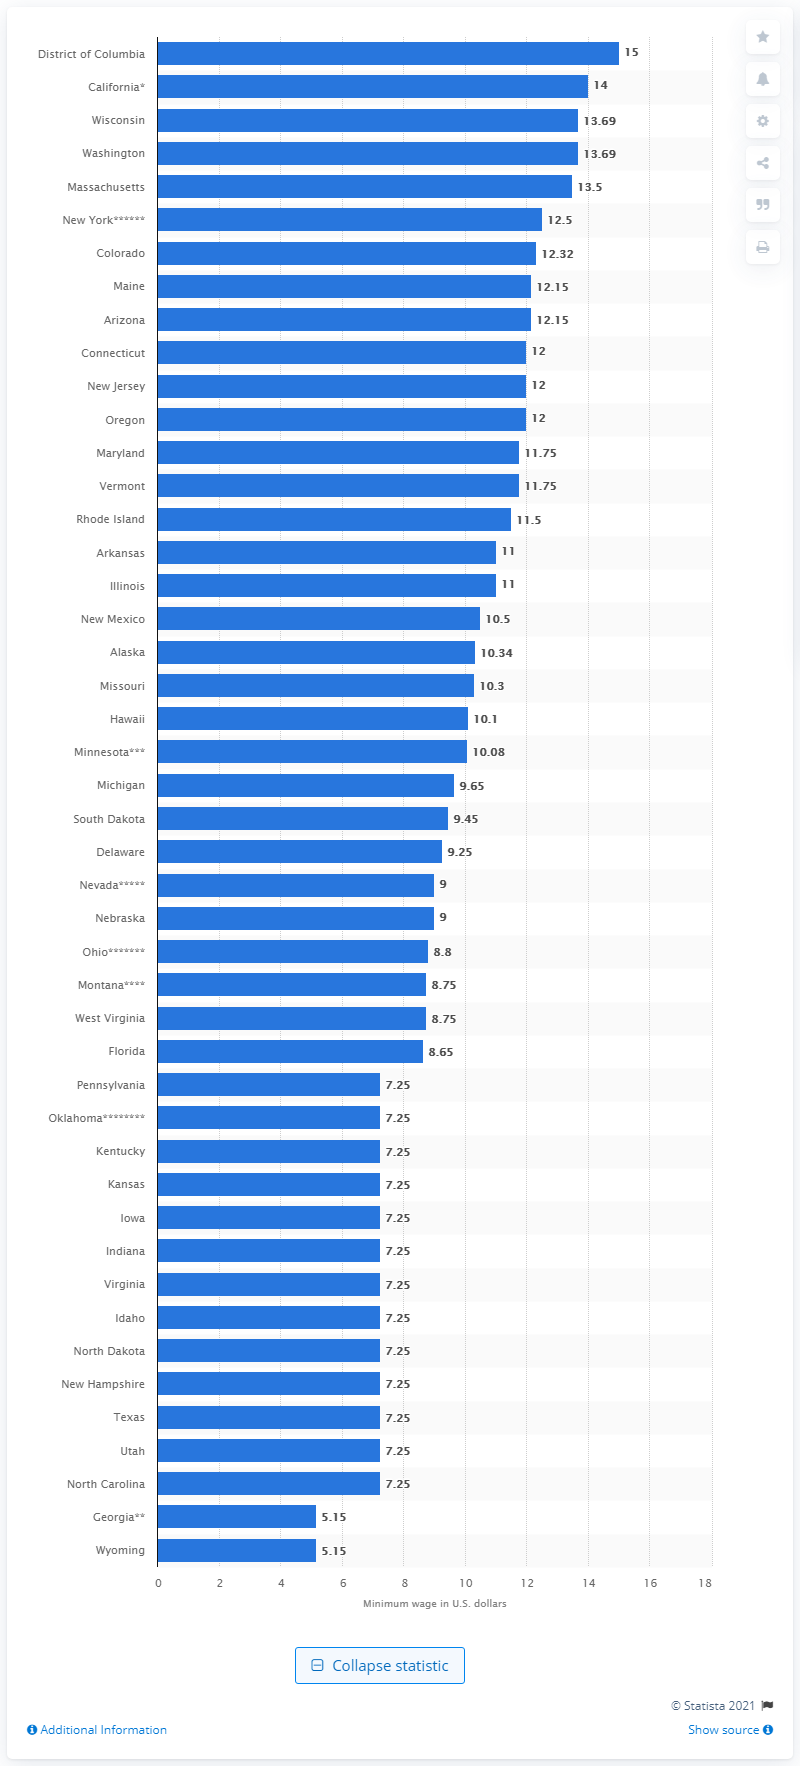Draw attention to some important aspects in this diagram. As of January 1, 2021, the minimum wage in Washington state was $13.50 per hour. The federal minimum wage per hour in the United States is 7.25. 